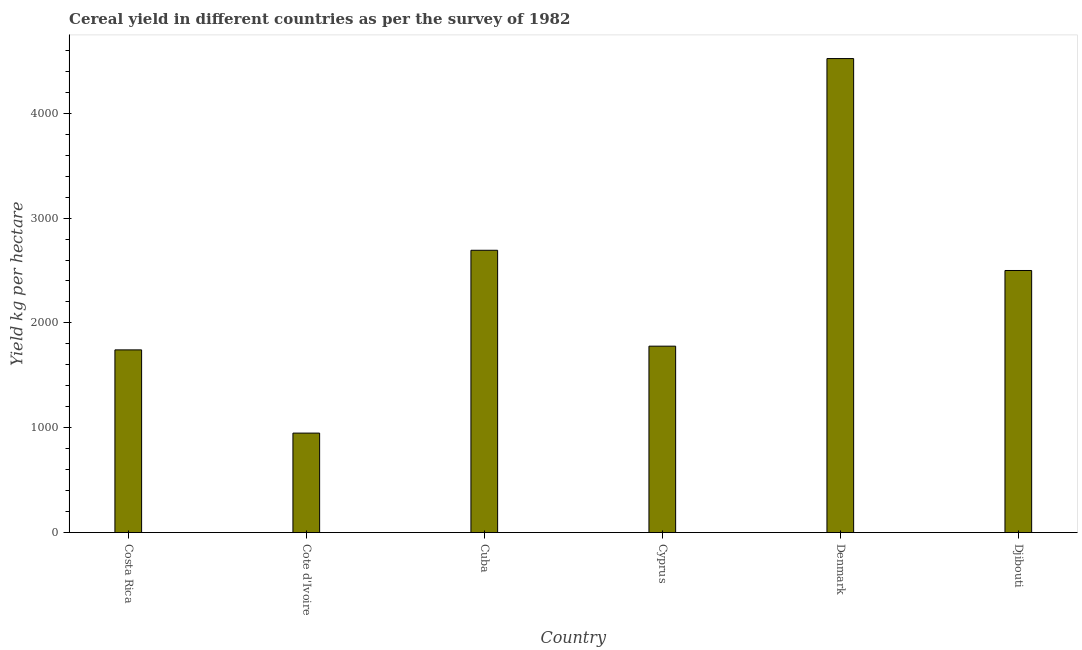Does the graph contain any zero values?
Make the answer very short. No. Does the graph contain grids?
Provide a short and direct response. No. What is the title of the graph?
Make the answer very short. Cereal yield in different countries as per the survey of 1982. What is the label or title of the X-axis?
Your answer should be very brief. Country. What is the label or title of the Y-axis?
Provide a short and direct response. Yield kg per hectare. What is the cereal yield in Denmark?
Your answer should be compact. 4521.33. Across all countries, what is the maximum cereal yield?
Your response must be concise. 4521.33. Across all countries, what is the minimum cereal yield?
Your response must be concise. 949. In which country was the cereal yield maximum?
Offer a terse response. Denmark. In which country was the cereal yield minimum?
Provide a short and direct response. Cote d'Ivoire. What is the sum of the cereal yield?
Make the answer very short. 1.42e+04. What is the difference between the cereal yield in Cote d'Ivoire and Djibouti?
Your answer should be very brief. -1551.01. What is the average cereal yield per country?
Your answer should be compact. 2364.01. What is the median cereal yield?
Offer a terse response. 2139.1. What is the ratio of the cereal yield in Cote d'Ivoire to that in Denmark?
Your response must be concise. 0.21. What is the difference between the highest and the second highest cereal yield?
Offer a very short reply. 1828.49. What is the difference between the highest and the lowest cereal yield?
Your response must be concise. 3572.33. How many bars are there?
Keep it short and to the point. 6. Are the values on the major ticks of Y-axis written in scientific E-notation?
Provide a short and direct response. No. What is the Yield kg per hectare in Costa Rica?
Offer a terse response. 1742.71. What is the Yield kg per hectare in Cote d'Ivoire?
Your answer should be compact. 949. What is the Yield kg per hectare in Cuba?
Keep it short and to the point. 2692.84. What is the Yield kg per hectare in Cyprus?
Keep it short and to the point. 1778.2. What is the Yield kg per hectare of Denmark?
Provide a succinct answer. 4521.33. What is the Yield kg per hectare in Djibouti?
Your response must be concise. 2500. What is the difference between the Yield kg per hectare in Costa Rica and Cote d'Ivoire?
Provide a short and direct response. 793.72. What is the difference between the Yield kg per hectare in Costa Rica and Cuba?
Provide a short and direct response. -950.13. What is the difference between the Yield kg per hectare in Costa Rica and Cyprus?
Provide a succinct answer. -35.49. What is the difference between the Yield kg per hectare in Costa Rica and Denmark?
Your answer should be compact. -2778.62. What is the difference between the Yield kg per hectare in Costa Rica and Djibouti?
Your answer should be very brief. -757.29. What is the difference between the Yield kg per hectare in Cote d'Ivoire and Cuba?
Provide a short and direct response. -1743.84. What is the difference between the Yield kg per hectare in Cote d'Ivoire and Cyprus?
Your answer should be very brief. -829.21. What is the difference between the Yield kg per hectare in Cote d'Ivoire and Denmark?
Keep it short and to the point. -3572.33. What is the difference between the Yield kg per hectare in Cote d'Ivoire and Djibouti?
Provide a short and direct response. -1551.01. What is the difference between the Yield kg per hectare in Cuba and Cyprus?
Provide a succinct answer. 914.64. What is the difference between the Yield kg per hectare in Cuba and Denmark?
Ensure brevity in your answer.  -1828.49. What is the difference between the Yield kg per hectare in Cuba and Djibouti?
Ensure brevity in your answer.  192.84. What is the difference between the Yield kg per hectare in Cyprus and Denmark?
Your response must be concise. -2743.13. What is the difference between the Yield kg per hectare in Cyprus and Djibouti?
Your response must be concise. -721.8. What is the difference between the Yield kg per hectare in Denmark and Djibouti?
Offer a terse response. 2021.33. What is the ratio of the Yield kg per hectare in Costa Rica to that in Cote d'Ivoire?
Give a very brief answer. 1.84. What is the ratio of the Yield kg per hectare in Costa Rica to that in Cuba?
Make the answer very short. 0.65. What is the ratio of the Yield kg per hectare in Costa Rica to that in Denmark?
Offer a terse response. 0.39. What is the ratio of the Yield kg per hectare in Costa Rica to that in Djibouti?
Your answer should be very brief. 0.7. What is the ratio of the Yield kg per hectare in Cote d'Ivoire to that in Cuba?
Give a very brief answer. 0.35. What is the ratio of the Yield kg per hectare in Cote d'Ivoire to that in Cyprus?
Give a very brief answer. 0.53. What is the ratio of the Yield kg per hectare in Cote d'Ivoire to that in Denmark?
Offer a very short reply. 0.21. What is the ratio of the Yield kg per hectare in Cote d'Ivoire to that in Djibouti?
Provide a short and direct response. 0.38. What is the ratio of the Yield kg per hectare in Cuba to that in Cyprus?
Offer a terse response. 1.51. What is the ratio of the Yield kg per hectare in Cuba to that in Denmark?
Provide a short and direct response. 0.6. What is the ratio of the Yield kg per hectare in Cuba to that in Djibouti?
Offer a terse response. 1.08. What is the ratio of the Yield kg per hectare in Cyprus to that in Denmark?
Make the answer very short. 0.39. What is the ratio of the Yield kg per hectare in Cyprus to that in Djibouti?
Give a very brief answer. 0.71. What is the ratio of the Yield kg per hectare in Denmark to that in Djibouti?
Provide a succinct answer. 1.81. 